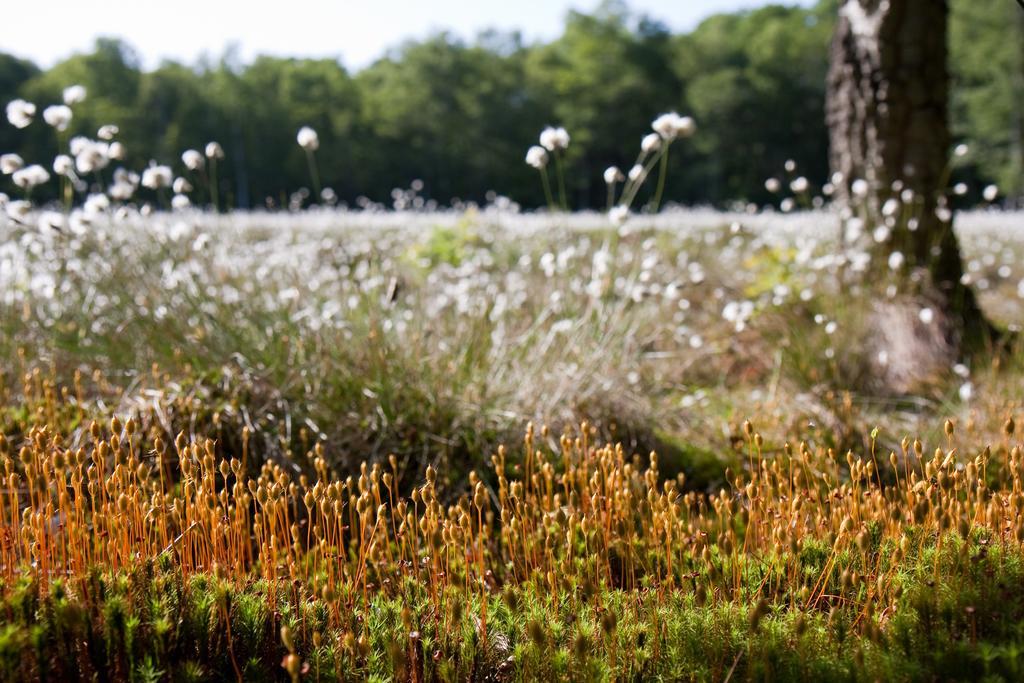In one or two sentences, can you explain what this image depicts? This image consists many plants and trees. In the middle, it looks like there are cotton plants. In the background, there are trees. At the top, there is sky. 